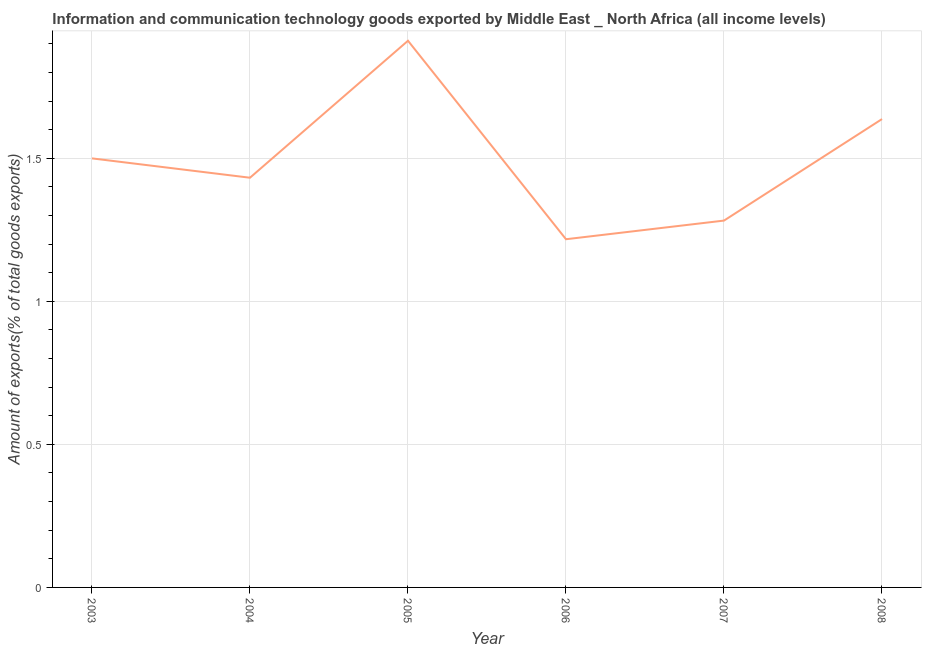What is the amount of ict goods exports in 2005?
Your answer should be compact. 1.91. Across all years, what is the maximum amount of ict goods exports?
Give a very brief answer. 1.91. Across all years, what is the minimum amount of ict goods exports?
Keep it short and to the point. 1.22. In which year was the amount of ict goods exports maximum?
Provide a short and direct response. 2005. In which year was the amount of ict goods exports minimum?
Offer a terse response. 2006. What is the sum of the amount of ict goods exports?
Make the answer very short. 8.98. What is the difference between the amount of ict goods exports in 2005 and 2006?
Make the answer very short. 0.69. What is the average amount of ict goods exports per year?
Offer a terse response. 1.5. What is the median amount of ict goods exports?
Your answer should be compact. 1.47. Do a majority of the years between 2004 and 2008 (inclusive) have amount of ict goods exports greater than 0.1 %?
Provide a short and direct response. Yes. What is the ratio of the amount of ict goods exports in 2003 to that in 2008?
Your answer should be very brief. 0.92. Is the amount of ict goods exports in 2005 less than that in 2008?
Provide a succinct answer. No. What is the difference between the highest and the second highest amount of ict goods exports?
Make the answer very short. 0.27. What is the difference between the highest and the lowest amount of ict goods exports?
Offer a very short reply. 0.69. Does the amount of ict goods exports monotonically increase over the years?
Make the answer very short. No. How many years are there in the graph?
Provide a succinct answer. 6. What is the difference between two consecutive major ticks on the Y-axis?
Give a very brief answer. 0.5. Does the graph contain grids?
Give a very brief answer. Yes. What is the title of the graph?
Provide a succinct answer. Information and communication technology goods exported by Middle East _ North Africa (all income levels). What is the label or title of the X-axis?
Your response must be concise. Year. What is the label or title of the Y-axis?
Offer a terse response. Amount of exports(% of total goods exports). What is the Amount of exports(% of total goods exports) of 2003?
Give a very brief answer. 1.5. What is the Amount of exports(% of total goods exports) of 2004?
Provide a succinct answer. 1.43. What is the Amount of exports(% of total goods exports) of 2005?
Your response must be concise. 1.91. What is the Amount of exports(% of total goods exports) in 2006?
Keep it short and to the point. 1.22. What is the Amount of exports(% of total goods exports) in 2007?
Give a very brief answer. 1.28. What is the Amount of exports(% of total goods exports) of 2008?
Provide a succinct answer. 1.64. What is the difference between the Amount of exports(% of total goods exports) in 2003 and 2004?
Offer a very short reply. 0.07. What is the difference between the Amount of exports(% of total goods exports) in 2003 and 2005?
Ensure brevity in your answer.  -0.41. What is the difference between the Amount of exports(% of total goods exports) in 2003 and 2006?
Ensure brevity in your answer.  0.28. What is the difference between the Amount of exports(% of total goods exports) in 2003 and 2007?
Offer a very short reply. 0.22. What is the difference between the Amount of exports(% of total goods exports) in 2003 and 2008?
Your answer should be compact. -0.14. What is the difference between the Amount of exports(% of total goods exports) in 2004 and 2005?
Your answer should be compact. -0.48. What is the difference between the Amount of exports(% of total goods exports) in 2004 and 2006?
Your answer should be compact. 0.22. What is the difference between the Amount of exports(% of total goods exports) in 2004 and 2007?
Ensure brevity in your answer.  0.15. What is the difference between the Amount of exports(% of total goods exports) in 2004 and 2008?
Offer a terse response. -0.21. What is the difference between the Amount of exports(% of total goods exports) in 2005 and 2006?
Make the answer very short. 0.69. What is the difference between the Amount of exports(% of total goods exports) in 2005 and 2007?
Your response must be concise. 0.63. What is the difference between the Amount of exports(% of total goods exports) in 2005 and 2008?
Your answer should be very brief. 0.27. What is the difference between the Amount of exports(% of total goods exports) in 2006 and 2007?
Provide a succinct answer. -0.07. What is the difference between the Amount of exports(% of total goods exports) in 2006 and 2008?
Ensure brevity in your answer.  -0.42. What is the difference between the Amount of exports(% of total goods exports) in 2007 and 2008?
Provide a succinct answer. -0.35. What is the ratio of the Amount of exports(% of total goods exports) in 2003 to that in 2004?
Offer a very short reply. 1.05. What is the ratio of the Amount of exports(% of total goods exports) in 2003 to that in 2005?
Give a very brief answer. 0.79. What is the ratio of the Amount of exports(% of total goods exports) in 2003 to that in 2006?
Your answer should be very brief. 1.23. What is the ratio of the Amount of exports(% of total goods exports) in 2003 to that in 2007?
Provide a succinct answer. 1.17. What is the ratio of the Amount of exports(% of total goods exports) in 2003 to that in 2008?
Your response must be concise. 0.92. What is the ratio of the Amount of exports(% of total goods exports) in 2004 to that in 2005?
Your answer should be compact. 0.75. What is the ratio of the Amount of exports(% of total goods exports) in 2004 to that in 2006?
Keep it short and to the point. 1.18. What is the ratio of the Amount of exports(% of total goods exports) in 2004 to that in 2007?
Offer a very short reply. 1.12. What is the ratio of the Amount of exports(% of total goods exports) in 2005 to that in 2006?
Your answer should be compact. 1.57. What is the ratio of the Amount of exports(% of total goods exports) in 2005 to that in 2007?
Ensure brevity in your answer.  1.49. What is the ratio of the Amount of exports(% of total goods exports) in 2005 to that in 2008?
Your answer should be very brief. 1.17. What is the ratio of the Amount of exports(% of total goods exports) in 2006 to that in 2007?
Your answer should be very brief. 0.95. What is the ratio of the Amount of exports(% of total goods exports) in 2006 to that in 2008?
Keep it short and to the point. 0.74. What is the ratio of the Amount of exports(% of total goods exports) in 2007 to that in 2008?
Offer a terse response. 0.78. 